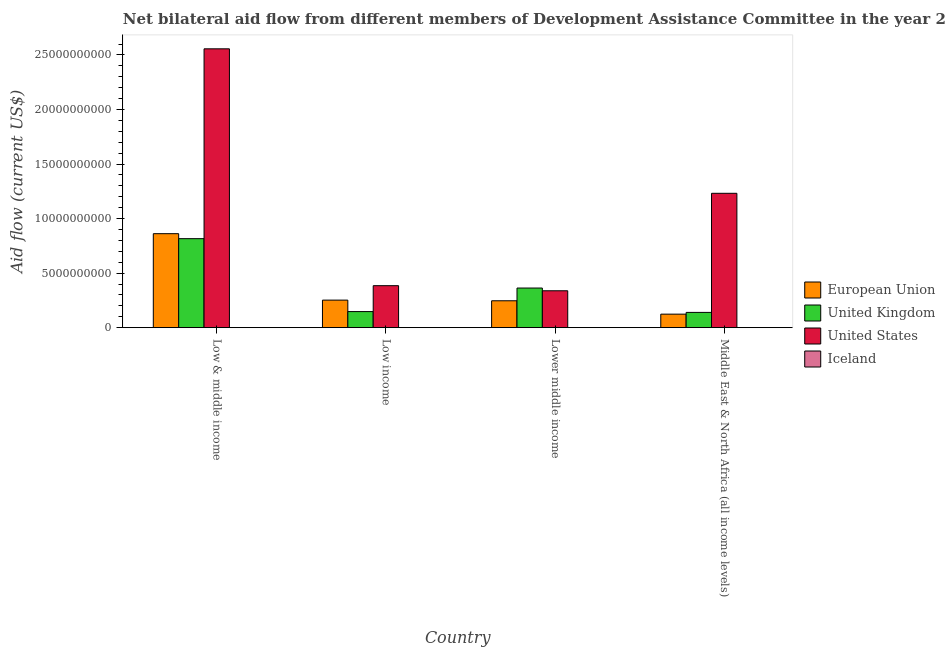How many groups of bars are there?
Offer a very short reply. 4. How many bars are there on the 1st tick from the right?
Your answer should be very brief. 4. What is the amount of aid given by uk in Low & middle income?
Offer a very short reply. 8.16e+09. Across all countries, what is the maximum amount of aid given by iceland?
Your answer should be very brief. 6.90e+06. Across all countries, what is the minimum amount of aid given by uk?
Offer a terse response. 1.40e+09. In which country was the amount of aid given by uk minimum?
Make the answer very short. Middle East & North Africa (all income levels). What is the total amount of aid given by iceland in the graph?
Your answer should be compact. 2.05e+07. What is the difference between the amount of aid given by eu in Low & middle income and that in Lower middle income?
Make the answer very short. 6.15e+09. What is the difference between the amount of aid given by us in Lower middle income and the amount of aid given by uk in Middle East & North Africa (all income levels)?
Ensure brevity in your answer.  1.98e+09. What is the average amount of aid given by uk per country?
Give a very brief answer. 3.67e+09. What is the difference between the amount of aid given by us and amount of aid given by iceland in Middle East & North Africa (all income levels)?
Your answer should be compact. 1.23e+1. In how many countries, is the amount of aid given by iceland greater than 20000000000 US$?
Make the answer very short. 0. What is the ratio of the amount of aid given by eu in Low income to that in Middle East & North Africa (all income levels)?
Keep it short and to the point. 2.04. Is the amount of aid given by uk in Low & middle income less than that in Low income?
Provide a succinct answer. No. Is the difference between the amount of aid given by us in Low & middle income and Middle East & North Africa (all income levels) greater than the difference between the amount of aid given by uk in Low & middle income and Middle East & North Africa (all income levels)?
Your response must be concise. Yes. What is the difference between the highest and the second highest amount of aid given by eu?
Provide a succinct answer. 6.09e+09. What is the difference between the highest and the lowest amount of aid given by iceland?
Offer a terse response. 4.22e+06. Are all the bars in the graph horizontal?
Your response must be concise. No. What is the difference between two consecutive major ticks on the Y-axis?
Your response must be concise. 5.00e+09. Are the values on the major ticks of Y-axis written in scientific E-notation?
Provide a short and direct response. No. Does the graph contain grids?
Make the answer very short. No. Where does the legend appear in the graph?
Your response must be concise. Center right. How many legend labels are there?
Ensure brevity in your answer.  4. What is the title of the graph?
Give a very brief answer. Net bilateral aid flow from different members of Development Assistance Committee in the year 2005. What is the label or title of the Y-axis?
Provide a succinct answer. Aid flow (current US$). What is the Aid flow (current US$) in European Union in Low & middle income?
Give a very brief answer. 8.61e+09. What is the Aid flow (current US$) of United Kingdom in Low & middle income?
Provide a succinct answer. 8.16e+09. What is the Aid flow (current US$) of United States in Low & middle income?
Your answer should be very brief. 2.56e+1. What is the Aid flow (current US$) in Iceland in Low & middle income?
Ensure brevity in your answer.  4.04e+06. What is the Aid flow (current US$) of European Union in Low income?
Your answer should be compact. 2.53e+09. What is the Aid flow (current US$) in United Kingdom in Low income?
Provide a succinct answer. 1.47e+09. What is the Aid flow (current US$) in United States in Low income?
Your answer should be very brief. 3.85e+09. What is the Aid flow (current US$) of Iceland in Low income?
Offer a very short reply. 6.90e+06. What is the Aid flow (current US$) in European Union in Lower middle income?
Provide a succinct answer. 2.46e+09. What is the Aid flow (current US$) of United Kingdom in Lower middle income?
Provide a succinct answer. 3.63e+09. What is the Aid flow (current US$) in United States in Lower middle income?
Offer a terse response. 3.38e+09. What is the Aid flow (current US$) of Iceland in Lower middle income?
Ensure brevity in your answer.  6.90e+06. What is the Aid flow (current US$) in European Union in Middle East & North Africa (all income levels)?
Make the answer very short. 1.24e+09. What is the Aid flow (current US$) in United Kingdom in Middle East & North Africa (all income levels)?
Provide a short and direct response. 1.40e+09. What is the Aid flow (current US$) in United States in Middle East & North Africa (all income levels)?
Make the answer very short. 1.23e+1. What is the Aid flow (current US$) of Iceland in Middle East & North Africa (all income levels)?
Offer a very short reply. 2.68e+06. Across all countries, what is the maximum Aid flow (current US$) in European Union?
Offer a terse response. 8.61e+09. Across all countries, what is the maximum Aid flow (current US$) in United Kingdom?
Your answer should be compact. 8.16e+09. Across all countries, what is the maximum Aid flow (current US$) in United States?
Keep it short and to the point. 2.56e+1. Across all countries, what is the maximum Aid flow (current US$) in Iceland?
Make the answer very short. 6.90e+06. Across all countries, what is the minimum Aid flow (current US$) in European Union?
Offer a terse response. 1.24e+09. Across all countries, what is the minimum Aid flow (current US$) of United Kingdom?
Offer a terse response. 1.40e+09. Across all countries, what is the minimum Aid flow (current US$) of United States?
Your answer should be very brief. 3.38e+09. Across all countries, what is the minimum Aid flow (current US$) in Iceland?
Provide a short and direct response. 2.68e+06. What is the total Aid flow (current US$) in European Union in the graph?
Your response must be concise. 1.48e+1. What is the total Aid flow (current US$) in United Kingdom in the graph?
Your answer should be compact. 1.47e+1. What is the total Aid flow (current US$) in United States in the graph?
Provide a short and direct response. 4.51e+1. What is the total Aid flow (current US$) in Iceland in the graph?
Give a very brief answer. 2.05e+07. What is the difference between the Aid flow (current US$) in European Union in Low & middle income and that in Low income?
Provide a succinct answer. 6.09e+09. What is the difference between the Aid flow (current US$) in United Kingdom in Low & middle income and that in Low income?
Offer a very short reply. 6.69e+09. What is the difference between the Aid flow (current US$) in United States in Low & middle income and that in Low income?
Make the answer very short. 2.17e+1. What is the difference between the Aid flow (current US$) of Iceland in Low & middle income and that in Low income?
Ensure brevity in your answer.  -2.86e+06. What is the difference between the Aid flow (current US$) of European Union in Low & middle income and that in Lower middle income?
Your response must be concise. 6.15e+09. What is the difference between the Aid flow (current US$) of United Kingdom in Low & middle income and that in Lower middle income?
Keep it short and to the point. 4.53e+09. What is the difference between the Aid flow (current US$) of United States in Low & middle income and that in Lower middle income?
Offer a terse response. 2.22e+1. What is the difference between the Aid flow (current US$) of Iceland in Low & middle income and that in Lower middle income?
Provide a succinct answer. -2.86e+06. What is the difference between the Aid flow (current US$) in European Union in Low & middle income and that in Middle East & North Africa (all income levels)?
Keep it short and to the point. 7.38e+09. What is the difference between the Aid flow (current US$) of United Kingdom in Low & middle income and that in Middle East & North Africa (all income levels)?
Ensure brevity in your answer.  6.76e+09. What is the difference between the Aid flow (current US$) in United States in Low & middle income and that in Middle East & North Africa (all income levels)?
Your response must be concise. 1.32e+1. What is the difference between the Aid flow (current US$) in Iceland in Low & middle income and that in Middle East & North Africa (all income levels)?
Your response must be concise. 1.36e+06. What is the difference between the Aid flow (current US$) of European Union in Low income and that in Lower middle income?
Give a very brief answer. 6.07e+07. What is the difference between the Aid flow (current US$) in United Kingdom in Low income and that in Lower middle income?
Offer a terse response. -2.16e+09. What is the difference between the Aid flow (current US$) in United States in Low income and that in Lower middle income?
Offer a terse response. 4.66e+08. What is the difference between the Aid flow (current US$) of European Union in Low income and that in Middle East & North Africa (all income levels)?
Your answer should be very brief. 1.29e+09. What is the difference between the Aid flow (current US$) in United Kingdom in Low income and that in Middle East & North Africa (all income levels)?
Your answer should be compact. 7.45e+07. What is the difference between the Aid flow (current US$) in United States in Low income and that in Middle East & North Africa (all income levels)?
Provide a short and direct response. -8.47e+09. What is the difference between the Aid flow (current US$) in Iceland in Low income and that in Middle East & North Africa (all income levels)?
Give a very brief answer. 4.22e+06. What is the difference between the Aid flow (current US$) of European Union in Lower middle income and that in Middle East & North Africa (all income levels)?
Provide a short and direct response. 1.23e+09. What is the difference between the Aid flow (current US$) in United Kingdom in Lower middle income and that in Middle East & North Africa (all income levels)?
Ensure brevity in your answer.  2.23e+09. What is the difference between the Aid flow (current US$) in United States in Lower middle income and that in Middle East & North Africa (all income levels)?
Offer a very short reply. -8.93e+09. What is the difference between the Aid flow (current US$) in Iceland in Lower middle income and that in Middle East & North Africa (all income levels)?
Provide a succinct answer. 4.22e+06. What is the difference between the Aid flow (current US$) of European Union in Low & middle income and the Aid flow (current US$) of United Kingdom in Low income?
Provide a succinct answer. 7.14e+09. What is the difference between the Aid flow (current US$) in European Union in Low & middle income and the Aid flow (current US$) in United States in Low income?
Offer a very short reply. 4.77e+09. What is the difference between the Aid flow (current US$) of European Union in Low & middle income and the Aid flow (current US$) of Iceland in Low income?
Your answer should be very brief. 8.61e+09. What is the difference between the Aid flow (current US$) in United Kingdom in Low & middle income and the Aid flow (current US$) in United States in Low income?
Make the answer very short. 4.31e+09. What is the difference between the Aid flow (current US$) in United Kingdom in Low & middle income and the Aid flow (current US$) in Iceland in Low income?
Give a very brief answer. 8.15e+09. What is the difference between the Aid flow (current US$) of United States in Low & middle income and the Aid flow (current US$) of Iceland in Low income?
Keep it short and to the point. 2.56e+1. What is the difference between the Aid flow (current US$) of European Union in Low & middle income and the Aid flow (current US$) of United Kingdom in Lower middle income?
Keep it short and to the point. 4.98e+09. What is the difference between the Aid flow (current US$) in European Union in Low & middle income and the Aid flow (current US$) in United States in Lower middle income?
Make the answer very short. 5.23e+09. What is the difference between the Aid flow (current US$) of European Union in Low & middle income and the Aid flow (current US$) of Iceland in Lower middle income?
Provide a short and direct response. 8.61e+09. What is the difference between the Aid flow (current US$) in United Kingdom in Low & middle income and the Aid flow (current US$) in United States in Lower middle income?
Offer a terse response. 4.78e+09. What is the difference between the Aid flow (current US$) in United Kingdom in Low & middle income and the Aid flow (current US$) in Iceland in Lower middle income?
Make the answer very short. 8.15e+09. What is the difference between the Aid flow (current US$) in United States in Low & middle income and the Aid flow (current US$) in Iceland in Lower middle income?
Your answer should be compact. 2.56e+1. What is the difference between the Aid flow (current US$) in European Union in Low & middle income and the Aid flow (current US$) in United Kingdom in Middle East & North Africa (all income levels)?
Offer a terse response. 7.22e+09. What is the difference between the Aid flow (current US$) of European Union in Low & middle income and the Aid flow (current US$) of United States in Middle East & North Africa (all income levels)?
Offer a terse response. -3.70e+09. What is the difference between the Aid flow (current US$) of European Union in Low & middle income and the Aid flow (current US$) of Iceland in Middle East & North Africa (all income levels)?
Keep it short and to the point. 8.61e+09. What is the difference between the Aid flow (current US$) in United Kingdom in Low & middle income and the Aid flow (current US$) in United States in Middle East & North Africa (all income levels)?
Offer a terse response. -4.16e+09. What is the difference between the Aid flow (current US$) in United Kingdom in Low & middle income and the Aid flow (current US$) in Iceland in Middle East & North Africa (all income levels)?
Keep it short and to the point. 8.16e+09. What is the difference between the Aid flow (current US$) in United States in Low & middle income and the Aid flow (current US$) in Iceland in Middle East & North Africa (all income levels)?
Your answer should be compact. 2.56e+1. What is the difference between the Aid flow (current US$) in European Union in Low income and the Aid flow (current US$) in United Kingdom in Lower middle income?
Your answer should be compact. -1.11e+09. What is the difference between the Aid flow (current US$) of European Union in Low income and the Aid flow (current US$) of United States in Lower middle income?
Your answer should be very brief. -8.57e+08. What is the difference between the Aid flow (current US$) in European Union in Low income and the Aid flow (current US$) in Iceland in Lower middle income?
Ensure brevity in your answer.  2.52e+09. What is the difference between the Aid flow (current US$) of United Kingdom in Low income and the Aid flow (current US$) of United States in Lower middle income?
Your answer should be very brief. -1.91e+09. What is the difference between the Aid flow (current US$) of United Kingdom in Low income and the Aid flow (current US$) of Iceland in Lower middle income?
Offer a terse response. 1.47e+09. What is the difference between the Aid flow (current US$) of United States in Low income and the Aid flow (current US$) of Iceland in Lower middle income?
Keep it short and to the point. 3.84e+09. What is the difference between the Aid flow (current US$) of European Union in Low income and the Aid flow (current US$) of United Kingdom in Middle East & North Africa (all income levels)?
Provide a succinct answer. 1.13e+09. What is the difference between the Aid flow (current US$) of European Union in Low income and the Aid flow (current US$) of United States in Middle East & North Africa (all income levels)?
Your answer should be compact. -9.79e+09. What is the difference between the Aid flow (current US$) in European Union in Low income and the Aid flow (current US$) in Iceland in Middle East & North Africa (all income levels)?
Make the answer very short. 2.52e+09. What is the difference between the Aid flow (current US$) of United Kingdom in Low income and the Aid flow (current US$) of United States in Middle East & North Africa (all income levels)?
Give a very brief answer. -1.08e+1. What is the difference between the Aid flow (current US$) of United Kingdom in Low income and the Aid flow (current US$) of Iceland in Middle East & North Africa (all income levels)?
Keep it short and to the point. 1.47e+09. What is the difference between the Aid flow (current US$) of United States in Low income and the Aid flow (current US$) of Iceland in Middle East & North Africa (all income levels)?
Provide a succinct answer. 3.85e+09. What is the difference between the Aid flow (current US$) of European Union in Lower middle income and the Aid flow (current US$) of United Kingdom in Middle East & North Africa (all income levels)?
Your answer should be very brief. 1.07e+09. What is the difference between the Aid flow (current US$) in European Union in Lower middle income and the Aid flow (current US$) in United States in Middle East & North Africa (all income levels)?
Offer a terse response. -9.85e+09. What is the difference between the Aid flow (current US$) in European Union in Lower middle income and the Aid flow (current US$) in Iceland in Middle East & North Africa (all income levels)?
Your answer should be compact. 2.46e+09. What is the difference between the Aid flow (current US$) in United Kingdom in Lower middle income and the Aid flow (current US$) in United States in Middle East & North Africa (all income levels)?
Offer a terse response. -8.68e+09. What is the difference between the Aid flow (current US$) of United Kingdom in Lower middle income and the Aid flow (current US$) of Iceland in Middle East & North Africa (all income levels)?
Keep it short and to the point. 3.63e+09. What is the difference between the Aid flow (current US$) of United States in Lower middle income and the Aid flow (current US$) of Iceland in Middle East & North Africa (all income levels)?
Your response must be concise. 3.38e+09. What is the average Aid flow (current US$) in European Union per country?
Your answer should be very brief. 3.71e+09. What is the average Aid flow (current US$) in United Kingdom per country?
Give a very brief answer. 3.67e+09. What is the average Aid flow (current US$) in United States per country?
Your answer should be very brief. 1.13e+1. What is the average Aid flow (current US$) of Iceland per country?
Keep it short and to the point. 5.13e+06. What is the difference between the Aid flow (current US$) of European Union and Aid flow (current US$) of United Kingdom in Low & middle income?
Your answer should be very brief. 4.56e+08. What is the difference between the Aid flow (current US$) of European Union and Aid flow (current US$) of United States in Low & middle income?
Give a very brief answer. -1.69e+1. What is the difference between the Aid flow (current US$) in European Union and Aid flow (current US$) in Iceland in Low & middle income?
Provide a succinct answer. 8.61e+09. What is the difference between the Aid flow (current US$) in United Kingdom and Aid flow (current US$) in United States in Low & middle income?
Your answer should be compact. -1.74e+1. What is the difference between the Aid flow (current US$) of United Kingdom and Aid flow (current US$) of Iceland in Low & middle income?
Your response must be concise. 8.15e+09. What is the difference between the Aid flow (current US$) of United States and Aid flow (current US$) of Iceland in Low & middle income?
Your response must be concise. 2.56e+1. What is the difference between the Aid flow (current US$) of European Union and Aid flow (current US$) of United Kingdom in Low income?
Your answer should be very brief. 1.05e+09. What is the difference between the Aid flow (current US$) of European Union and Aid flow (current US$) of United States in Low income?
Offer a terse response. -1.32e+09. What is the difference between the Aid flow (current US$) in European Union and Aid flow (current US$) in Iceland in Low income?
Provide a short and direct response. 2.52e+09. What is the difference between the Aid flow (current US$) in United Kingdom and Aid flow (current US$) in United States in Low income?
Provide a succinct answer. -2.38e+09. What is the difference between the Aid flow (current US$) in United Kingdom and Aid flow (current US$) in Iceland in Low income?
Your answer should be very brief. 1.47e+09. What is the difference between the Aid flow (current US$) in United States and Aid flow (current US$) in Iceland in Low income?
Keep it short and to the point. 3.84e+09. What is the difference between the Aid flow (current US$) in European Union and Aid flow (current US$) in United Kingdom in Lower middle income?
Provide a succinct answer. -1.17e+09. What is the difference between the Aid flow (current US$) in European Union and Aid flow (current US$) in United States in Lower middle income?
Your answer should be very brief. -9.17e+08. What is the difference between the Aid flow (current US$) in European Union and Aid flow (current US$) in Iceland in Lower middle income?
Make the answer very short. 2.46e+09. What is the difference between the Aid flow (current US$) in United Kingdom and Aid flow (current US$) in United States in Lower middle income?
Ensure brevity in your answer.  2.50e+08. What is the difference between the Aid flow (current US$) of United Kingdom and Aid flow (current US$) of Iceland in Lower middle income?
Give a very brief answer. 3.63e+09. What is the difference between the Aid flow (current US$) of United States and Aid flow (current US$) of Iceland in Lower middle income?
Make the answer very short. 3.38e+09. What is the difference between the Aid flow (current US$) of European Union and Aid flow (current US$) of United Kingdom in Middle East & North Africa (all income levels)?
Offer a terse response. -1.59e+08. What is the difference between the Aid flow (current US$) of European Union and Aid flow (current US$) of United States in Middle East & North Africa (all income levels)?
Give a very brief answer. -1.11e+1. What is the difference between the Aid flow (current US$) in European Union and Aid flow (current US$) in Iceland in Middle East & North Africa (all income levels)?
Your answer should be compact. 1.24e+09. What is the difference between the Aid flow (current US$) in United Kingdom and Aid flow (current US$) in United States in Middle East & North Africa (all income levels)?
Offer a very short reply. -1.09e+1. What is the difference between the Aid flow (current US$) in United Kingdom and Aid flow (current US$) in Iceland in Middle East & North Africa (all income levels)?
Your response must be concise. 1.40e+09. What is the difference between the Aid flow (current US$) in United States and Aid flow (current US$) in Iceland in Middle East & North Africa (all income levels)?
Ensure brevity in your answer.  1.23e+1. What is the ratio of the Aid flow (current US$) in European Union in Low & middle income to that in Low income?
Give a very brief answer. 3.41. What is the ratio of the Aid flow (current US$) of United Kingdom in Low & middle income to that in Low income?
Provide a short and direct response. 5.54. What is the ratio of the Aid flow (current US$) of United States in Low & middle income to that in Low income?
Make the answer very short. 6.64. What is the ratio of the Aid flow (current US$) of Iceland in Low & middle income to that in Low income?
Your response must be concise. 0.59. What is the ratio of the Aid flow (current US$) of European Union in Low & middle income to that in Lower middle income?
Your answer should be very brief. 3.5. What is the ratio of the Aid flow (current US$) in United Kingdom in Low & middle income to that in Lower middle income?
Your answer should be compact. 2.25. What is the ratio of the Aid flow (current US$) in United States in Low & middle income to that in Lower middle income?
Offer a terse response. 7.56. What is the ratio of the Aid flow (current US$) in Iceland in Low & middle income to that in Lower middle income?
Keep it short and to the point. 0.59. What is the ratio of the Aid flow (current US$) in European Union in Low & middle income to that in Middle East & North Africa (all income levels)?
Your answer should be very brief. 6.95. What is the ratio of the Aid flow (current US$) in United Kingdom in Low & middle income to that in Middle East & North Africa (all income levels)?
Your response must be concise. 5.83. What is the ratio of the Aid flow (current US$) in United States in Low & middle income to that in Middle East & North Africa (all income levels)?
Offer a terse response. 2.08. What is the ratio of the Aid flow (current US$) of Iceland in Low & middle income to that in Middle East & North Africa (all income levels)?
Keep it short and to the point. 1.51. What is the ratio of the Aid flow (current US$) in European Union in Low income to that in Lower middle income?
Offer a very short reply. 1.02. What is the ratio of the Aid flow (current US$) of United Kingdom in Low income to that in Lower middle income?
Your response must be concise. 0.41. What is the ratio of the Aid flow (current US$) in United States in Low income to that in Lower middle income?
Provide a short and direct response. 1.14. What is the ratio of the Aid flow (current US$) in European Union in Low income to that in Middle East & North Africa (all income levels)?
Make the answer very short. 2.04. What is the ratio of the Aid flow (current US$) in United Kingdom in Low income to that in Middle East & North Africa (all income levels)?
Give a very brief answer. 1.05. What is the ratio of the Aid flow (current US$) in United States in Low income to that in Middle East & North Africa (all income levels)?
Your answer should be very brief. 0.31. What is the ratio of the Aid flow (current US$) in Iceland in Low income to that in Middle East & North Africa (all income levels)?
Provide a short and direct response. 2.57. What is the ratio of the Aid flow (current US$) in European Union in Lower middle income to that in Middle East & North Africa (all income levels)?
Your response must be concise. 1.99. What is the ratio of the Aid flow (current US$) of United Kingdom in Lower middle income to that in Middle East & North Africa (all income levels)?
Your answer should be very brief. 2.6. What is the ratio of the Aid flow (current US$) in United States in Lower middle income to that in Middle East & North Africa (all income levels)?
Keep it short and to the point. 0.27. What is the ratio of the Aid flow (current US$) in Iceland in Lower middle income to that in Middle East & North Africa (all income levels)?
Offer a terse response. 2.57. What is the difference between the highest and the second highest Aid flow (current US$) of European Union?
Give a very brief answer. 6.09e+09. What is the difference between the highest and the second highest Aid flow (current US$) of United Kingdom?
Your answer should be very brief. 4.53e+09. What is the difference between the highest and the second highest Aid flow (current US$) of United States?
Give a very brief answer. 1.32e+1. What is the difference between the highest and the second highest Aid flow (current US$) in Iceland?
Your answer should be compact. 0. What is the difference between the highest and the lowest Aid flow (current US$) of European Union?
Make the answer very short. 7.38e+09. What is the difference between the highest and the lowest Aid flow (current US$) in United Kingdom?
Provide a short and direct response. 6.76e+09. What is the difference between the highest and the lowest Aid flow (current US$) in United States?
Give a very brief answer. 2.22e+1. What is the difference between the highest and the lowest Aid flow (current US$) in Iceland?
Your answer should be compact. 4.22e+06. 